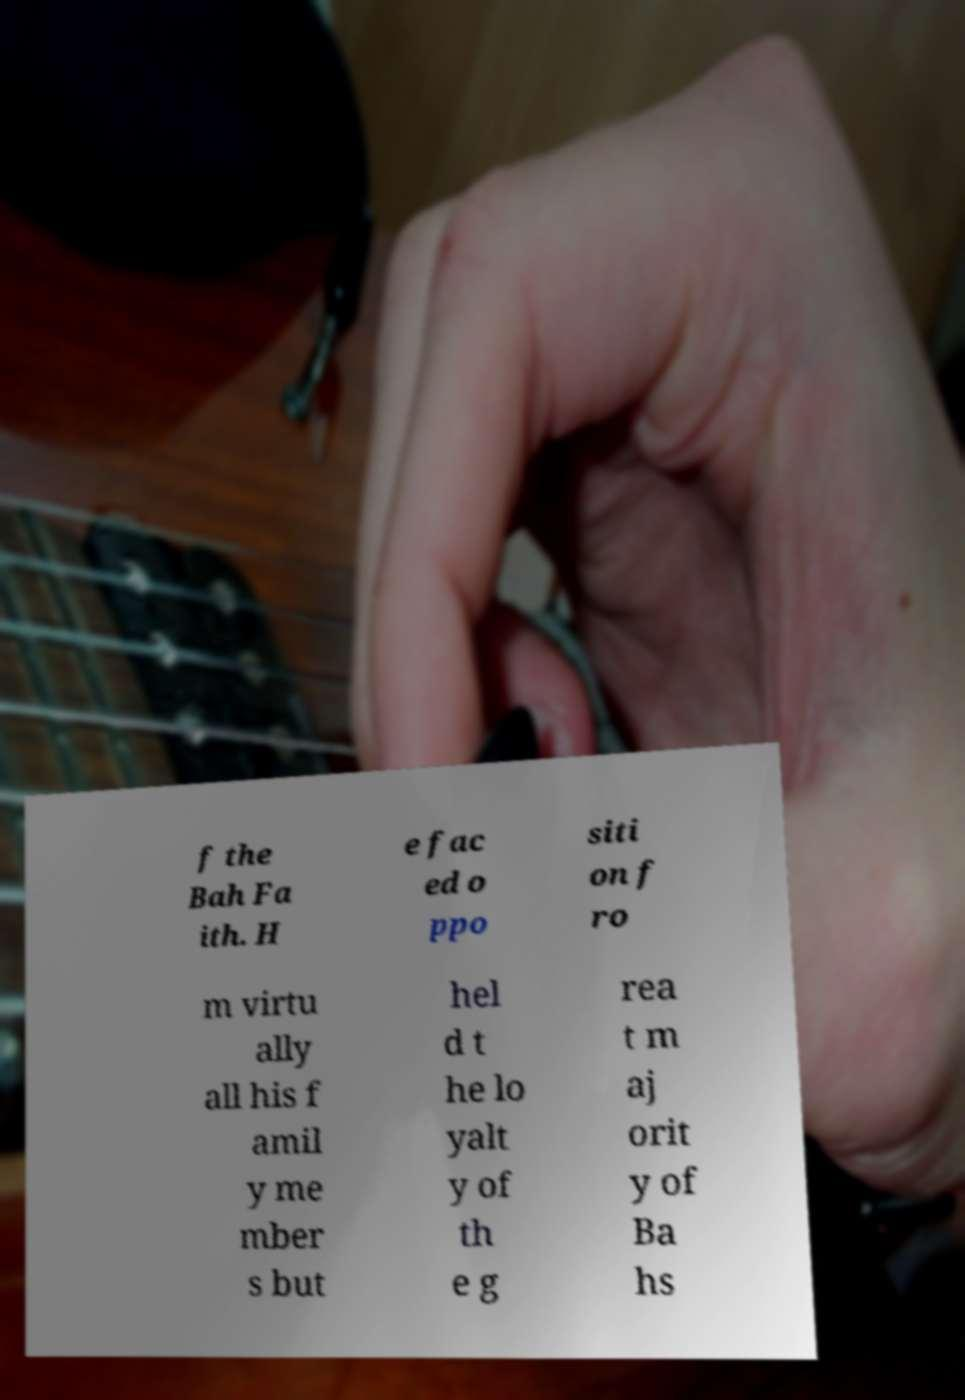There's text embedded in this image that I need extracted. Can you transcribe it verbatim? f the Bah Fa ith. H e fac ed o ppo siti on f ro m virtu ally all his f amil y me mber s but hel d t he lo yalt y of th e g rea t m aj orit y of Ba hs 